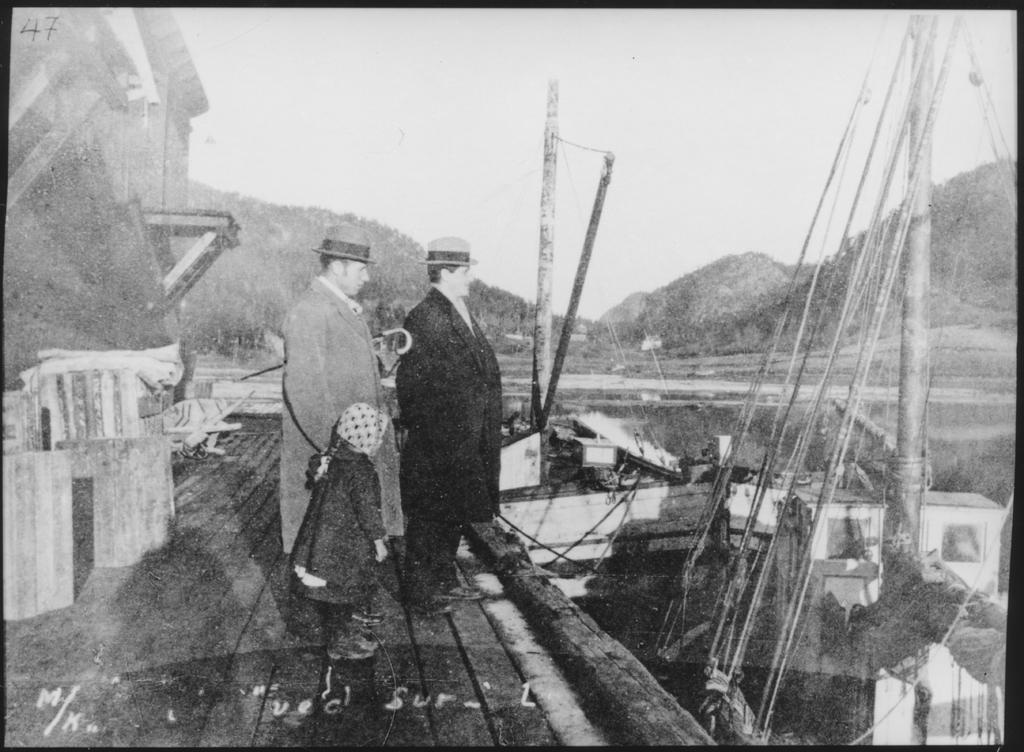Can you describe this image briefly? In this picture we can see few people, they wore caps, in front of them we can find few boats, in the background we can see hills, and it is a black and white photography. 